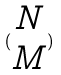<formula> <loc_0><loc_0><loc_500><loc_500>( \begin{matrix} N \\ M \end{matrix} )</formula> 